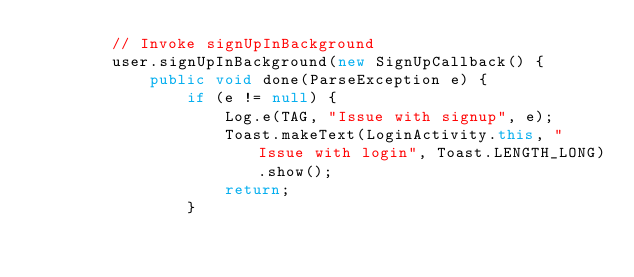Convert code to text. <code><loc_0><loc_0><loc_500><loc_500><_Java_>        // Invoke signUpInBackground
        user.signUpInBackground(new SignUpCallback() {
            public void done(ParseException e) {
                if (e != null) {
                    Log.e(TAG, "Issue with signup", e);
                    Toast.makeText(LoginActivity.this, "Issue with login", Toast.LENGTH_LONG).show();
                    return;
                }</code> 